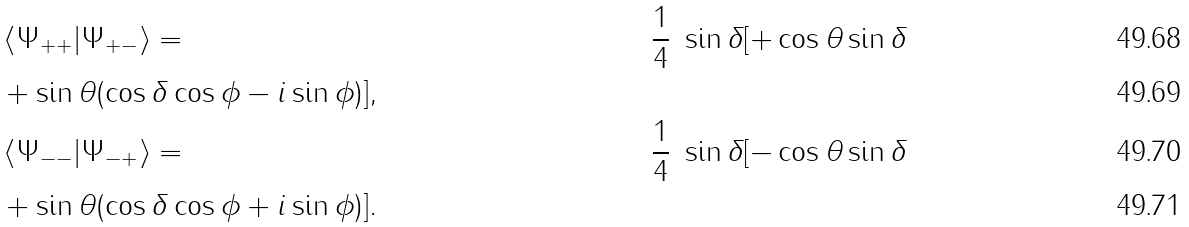Convert formula to latex. <formula><loc_0><loc_0><loc_500><loc_500>& \left \langle \Psi _ { + + } | \Psi _ { + - } \right \rangle = & \frac { 1 } { 4 } \ \sin \delta [ + \cos \theta \sin \delta \\ & + \sin \theta ( \cos \delta \cos \phi - i \sin \phi ) ] , \\ & \left \langle \Psi _ { - - } | \Psi _ { - + } \right \rangle = & \frac { 1 } { 4 } \ \sin \delta [ - \cos \theta \sin \delta \\ & + \sin \theta ( \cos \delta \cos \phi + i \sin \phi ) ] .</formula> 